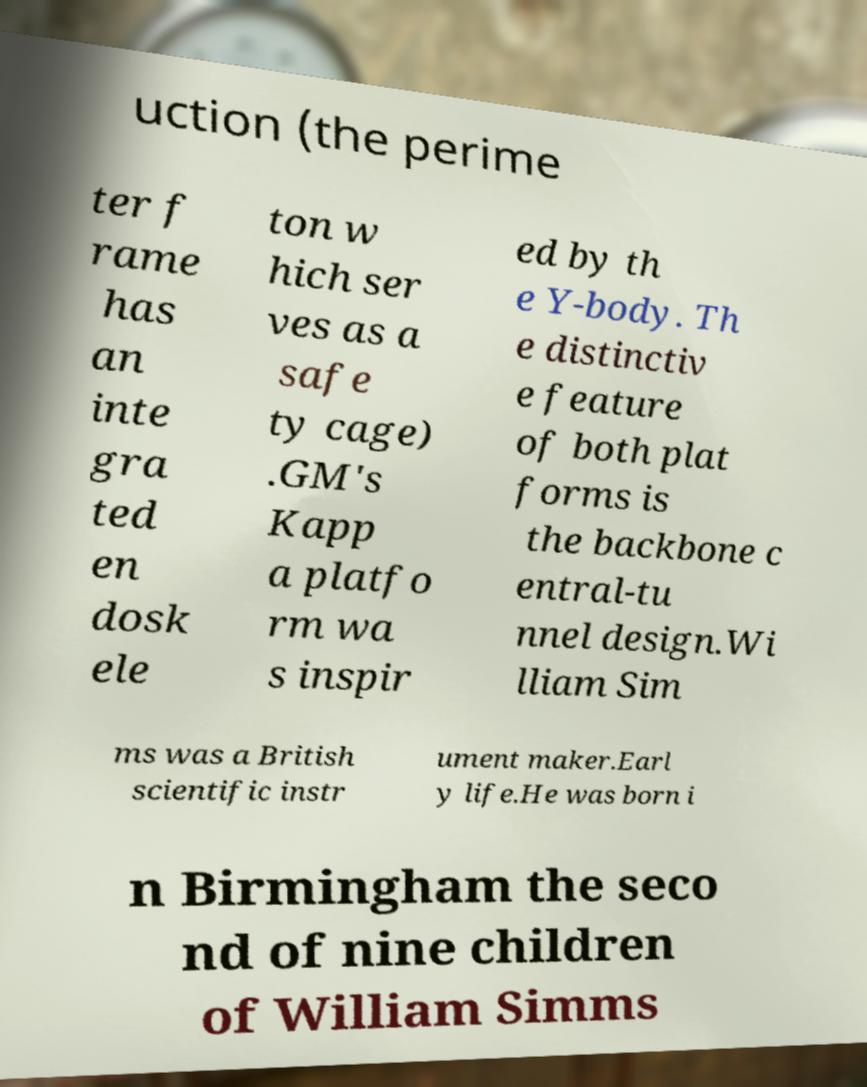There's text embedded in this image that I need extracted. Can you transcribe it verbatim? uction (the perime ter f rame has an inte gra ted en dosk ele ton w hich ser ves as a safe ty cage) .GM's Kapp a platfo rm wa s inspir ed by th e Y-body. Th e distinctiv e feature of both plat forms is the backbone c entral-tu nnel design.Wi lliam Sim ms was a British scientific instr ument maker.Earl y life.He was born i n Birmingham the seco nd of nine children of William Simms 